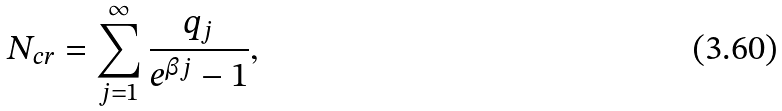<formula> <loc_0><loc_0><loc_500><loc_500>N _ { c r } = \sum _ { j = 1 } ^ { \infty } \frac { q _ { j } } { e ^ { \beta j } - 1 } ,</formula> 